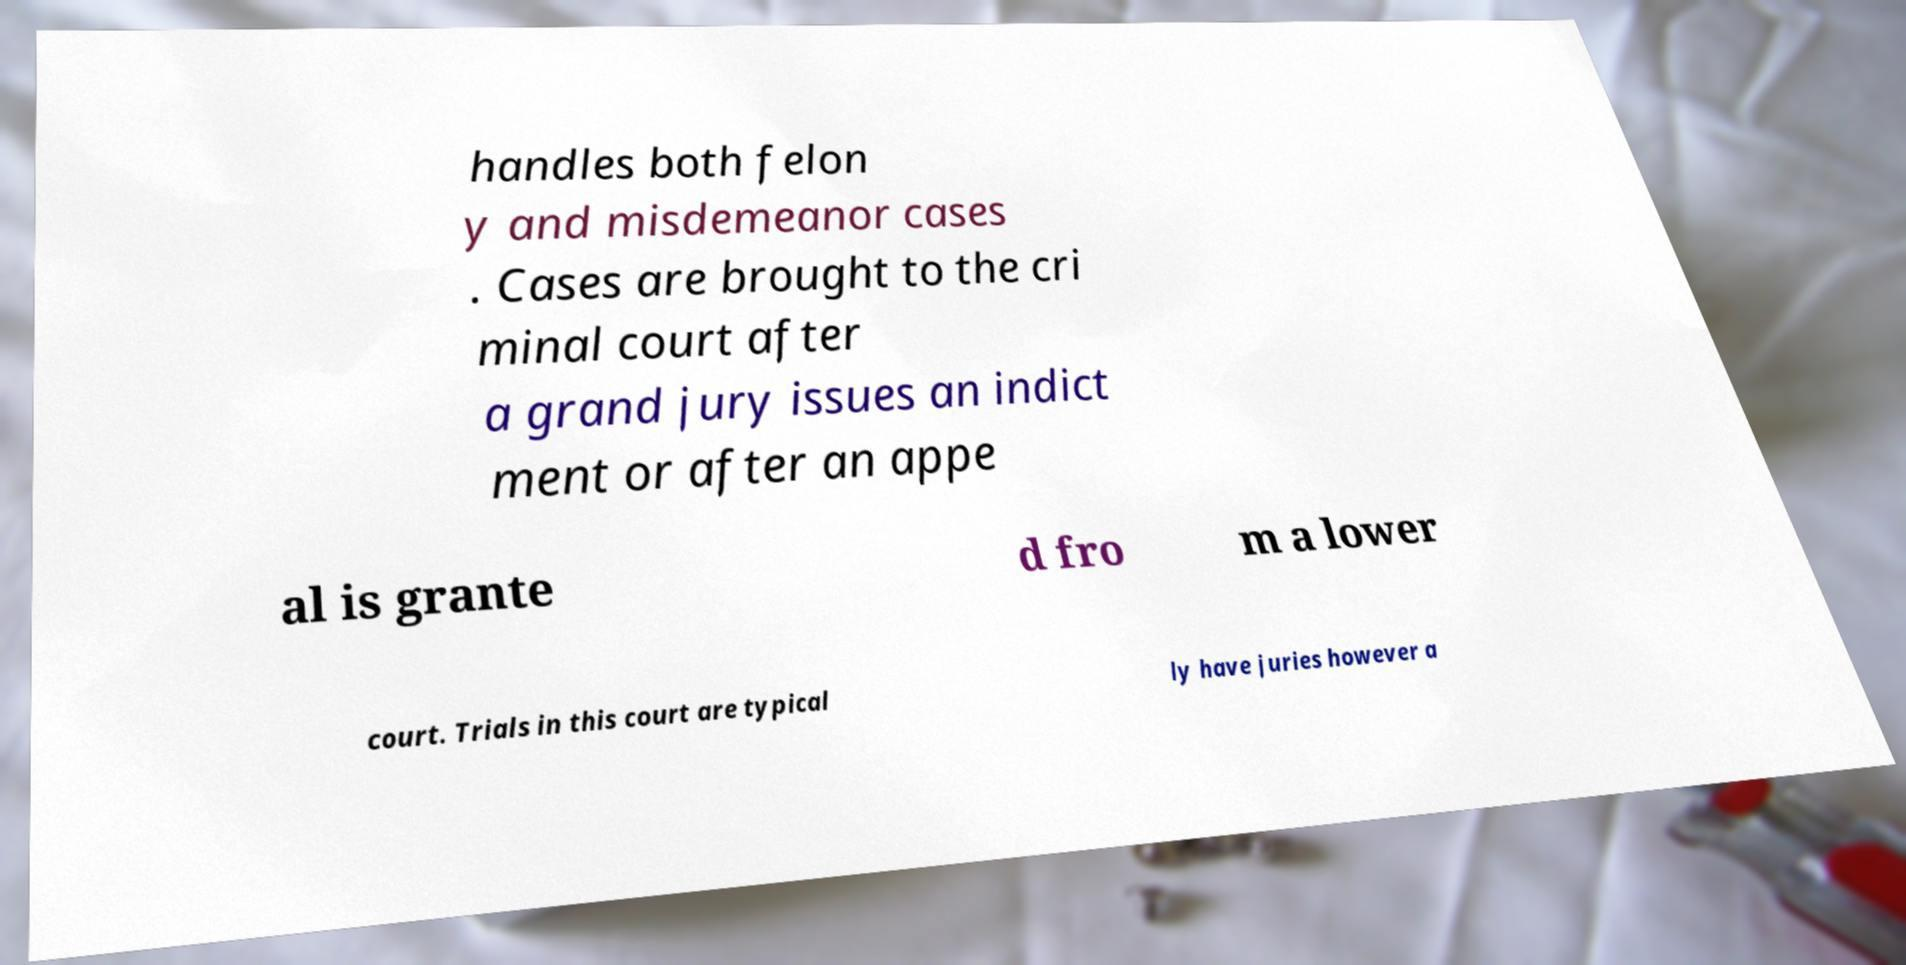Please read and relay the text visible in this image. What does it say? handles both felon y and misdemeanor cases . Cases are brought to the cri minal court after a grand jury issues an indict ment or after an appe al is grante d fro m a lower court. Trials in this court are typical ly have juries however a 